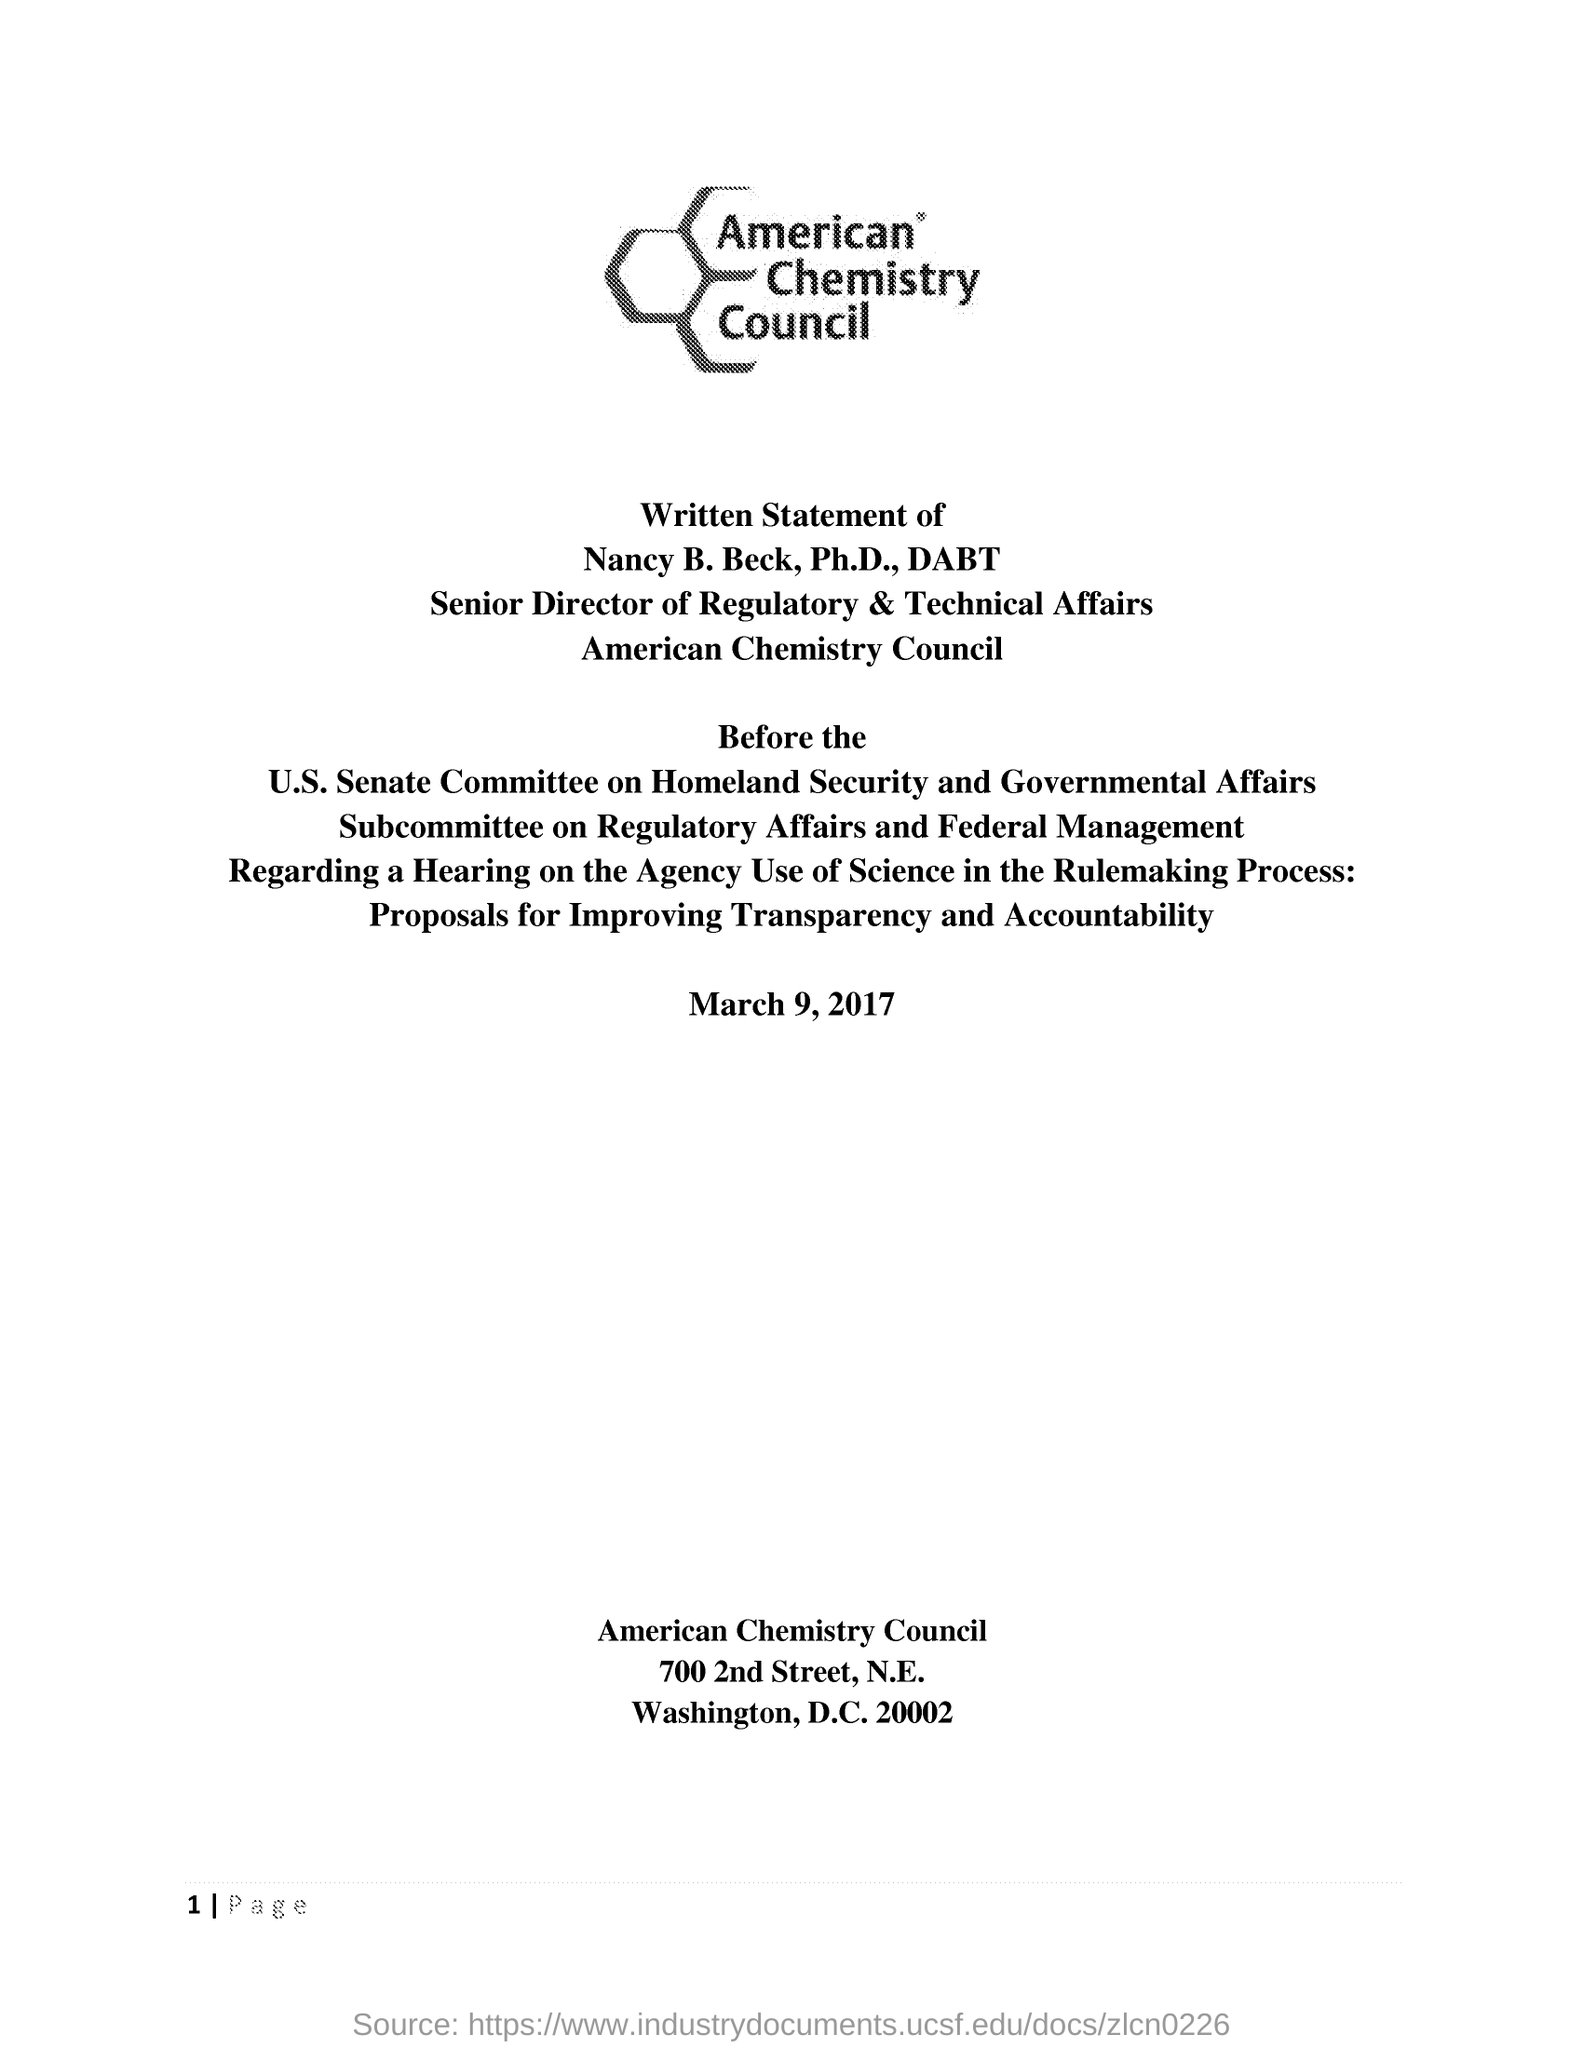Draw attention to some important aspects in this diagram. The American Chemistry Council is mentioned at the top of the document. The Written Statement was dated March 9, 2017. 